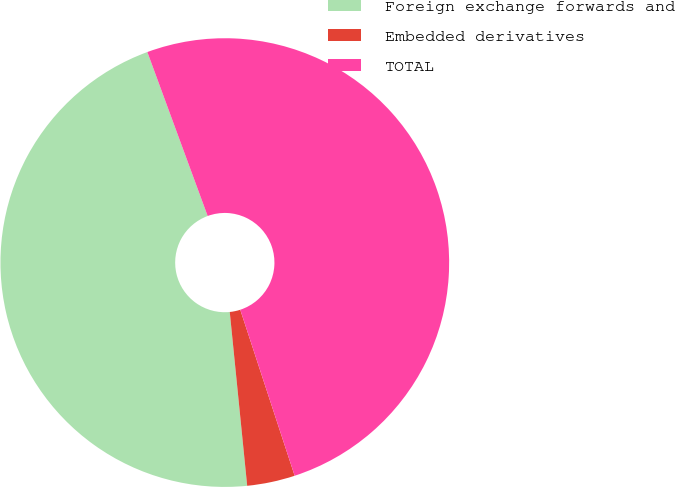Convert chart to OTSL. <chart><loc_0><loc_0><loc_500><loc_500><pie_chart><fcel>Foreign exchange forwards and<fcel>Embedded derivatives<fcel>TOTAL<nl><fcel>45.98%<fcel>3.45%<fcel>50.57%<nl></chart> 